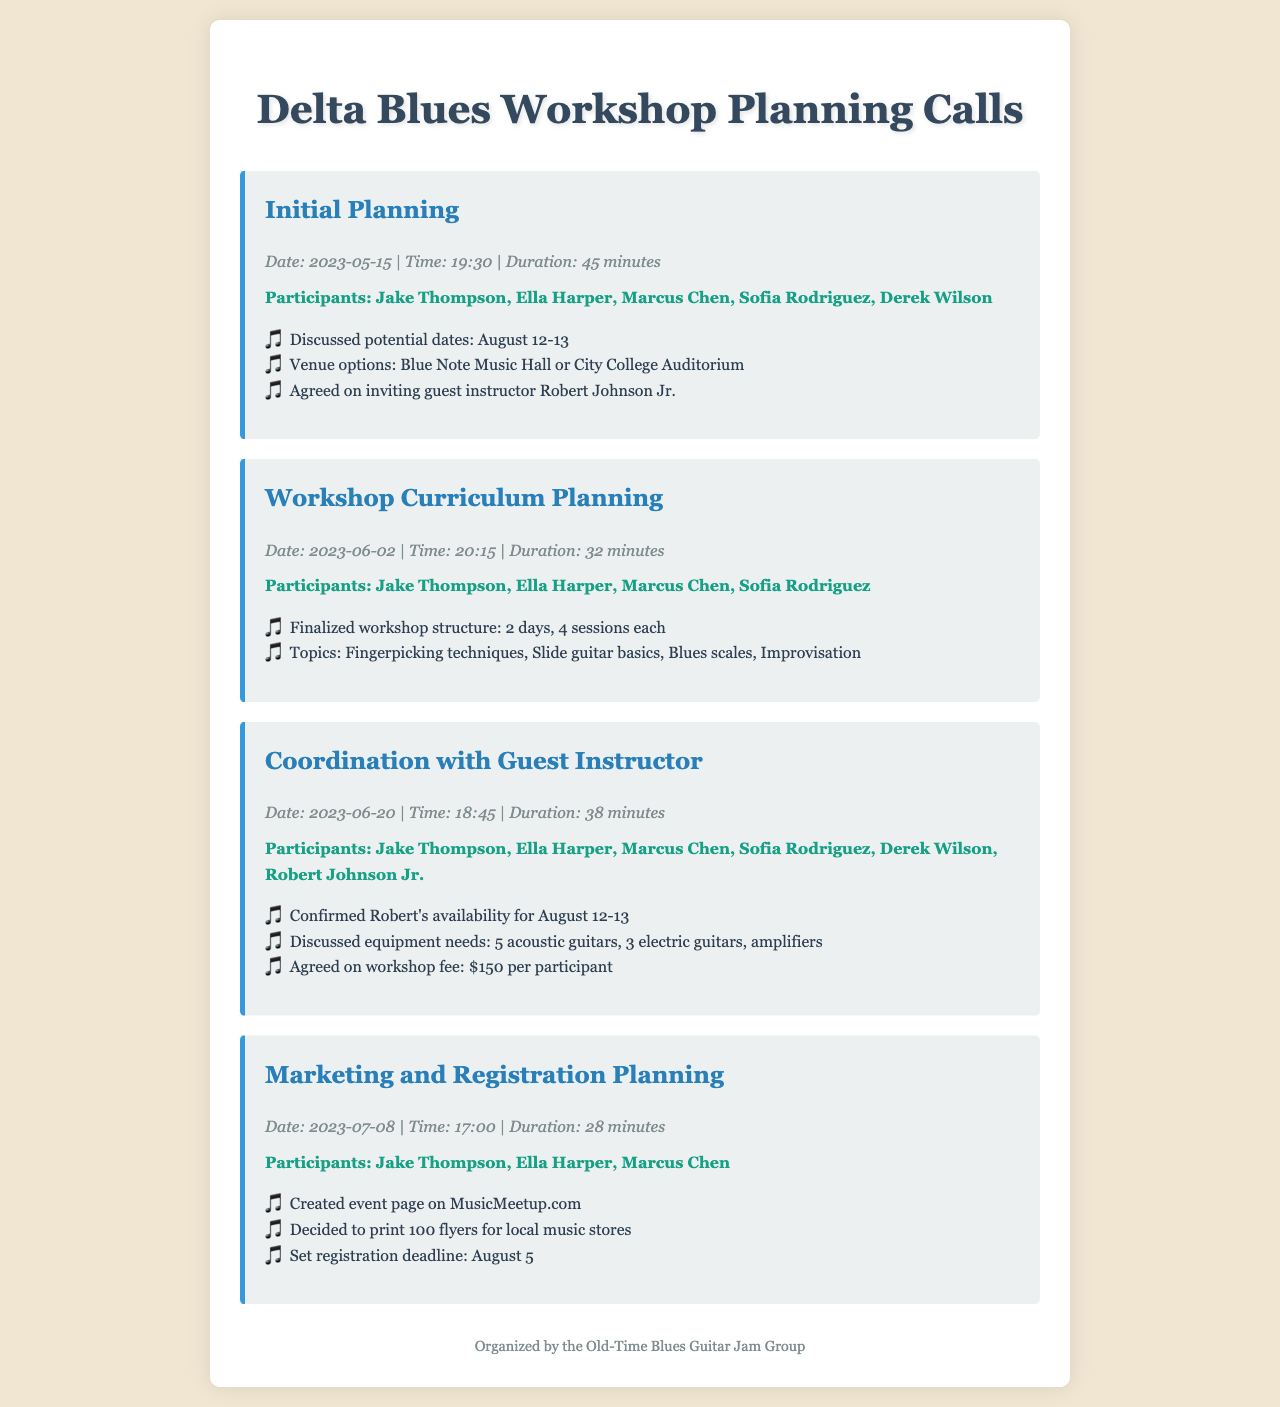What was the date of the initial planning call? The date of the initial planning call is explicitly mentioned in the document.
Answer: 2023-05-15 How many participants were on the call about marketing and registration planning? The number of participants is indicated in the document.
Answer: 3 What is the duration of the coordination with guest instructor call? The duration of the call is provided in the call information section.
Answer: 38 minutes Which venue was discussed for the workshop in the initial planning call? The document specifies the venue options considered during the call.
Answer: Blue Note Music Hall or City College Auditorium What was the agreed workshop fee per participant? The fee agreed upon for the workshop is clearly stated in the coordination with guest instructor section.
Answer: $150 per participant Which topics were part of the finalized workshop structure? The document lists the topics discussed during the workshop curriculum planning.
Answer: Fingerpicking techniques, Slide guitar basics, Blues scales, Improvisation What was the registration deadline set during the marketing planning call? The registration deadline is noted in the key points from the marketing and registration planning call.
Answer: August 5 Who was confirmed as the guest instructor for the workshop? The name of the guest instructor is mentioned in the coordination with guest instructor call details.
Answer: Robert Johnson Jr What time was the workshop curriculum planning call held? The time of the call is mentioned in the call information section.
Answer: 20:15 